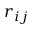<formula> <loc_0><loc_0><loc_500><loc_500>r _ { i j }</formula> 